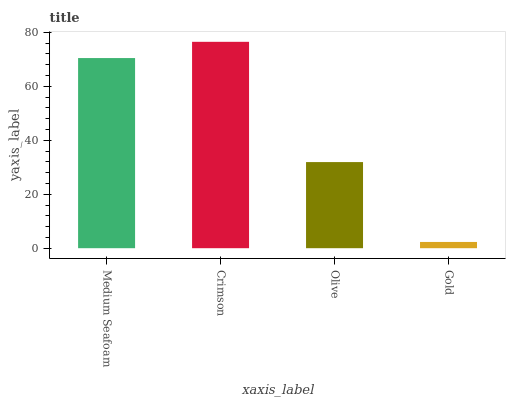Is Gold the minimum?
Answer yes or no. Yes. Is Crimson the maximum?
Answer yes or no. Yes. Is Olive the minimum?
Answer yes or no. No. Is Olive the maximum?
Answer yes or no. No. Is Crimson greater than Olive?
Answer yes or no. Yes. Is Olive less than Crimson?
Answer yes or no. Yes. Is Olive greater than Crimson?
Answer yes or no. No. Is Crimson less than Olive?
Answer yes or no. No. Is Medium Seafoam the high median?
Answer yes or no. Yes. Is Olive the low median?
Answer yes or no. Yes. Is Olive the high median?
Answer yes or no. No. Is Medium Seafoam the low median?
Answer yes or no. No. 